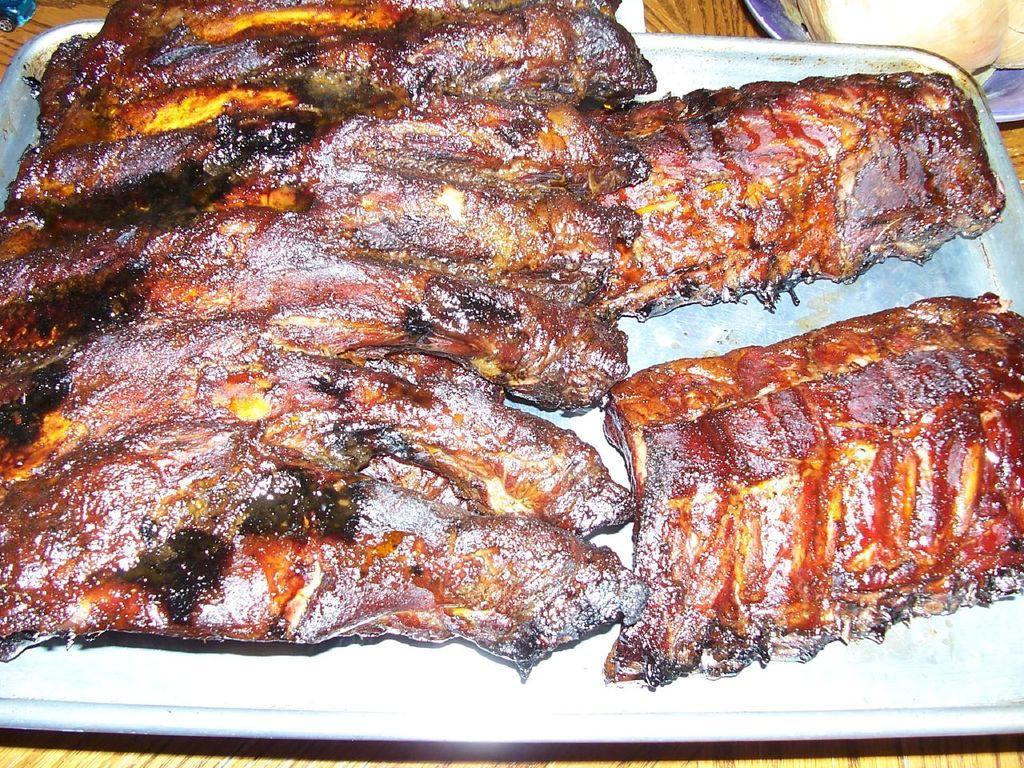Describe this image in one or two sentences. In this image I can see some food item in the plate. In the background, I can see the table. 